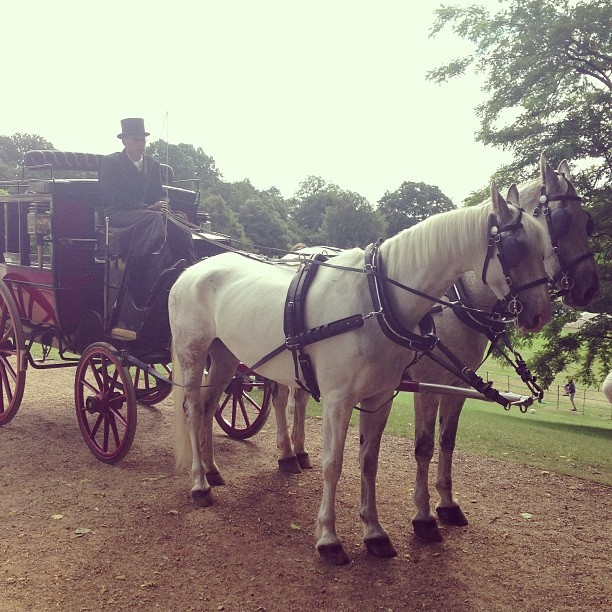Describe the objects in this image and their specific colors. I can see horse in beige, darkgray, gray, and purple tones, horse in beige, purple, gray, and black tones, and people in beige, gray, and purple tones in this image. 